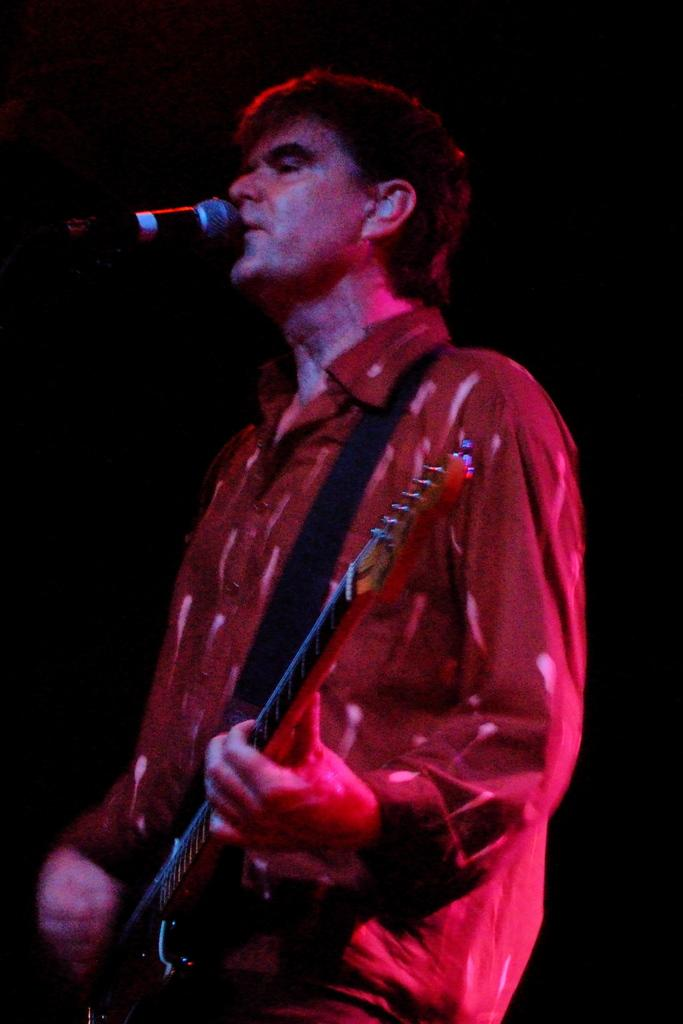What is the man in the image doing? The man is singing in the image. What is the man holding while singing? The man is holding a microphone. What musical instrument is the man playing? The man is playing a guitar. What type of fruit is the man using as a prop while playing the guitar? There is no fruit present in the image, and the man is not using any props while playing the guitar. 